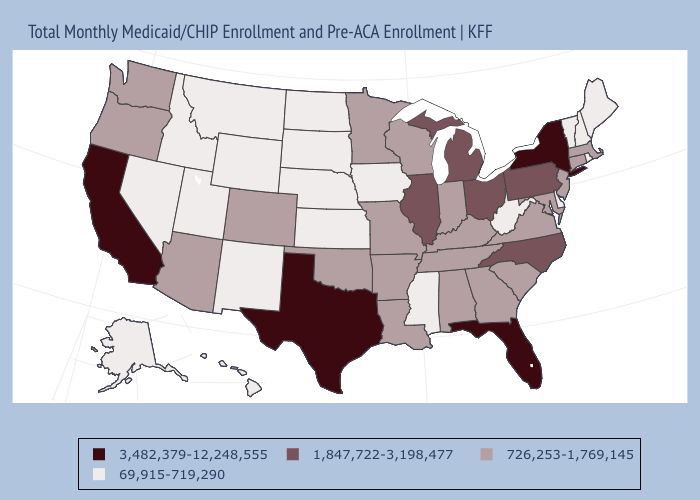What is the value of New York?
Write a very short answer. 3,482,379-12,248,555. Does Ohio have a higher value than Texas?
Short answer required. No. Name the states that have a value in the range 3,482,379-12,248,555?
Answer briefly. California, Florida, New York, Texas. What is the value of Maryland?
Answer briefly. 726,253-1,769,145. What is the highest value in the USA?
Be succinct. 3,482,379-12,248,555. Does Colorado have the same value as Wyoming?
Give a very brief answer. No. What is the value of Vermont?
Concise answer only. 69,915-719,290. What is the value of Minnesota?
Answer briefly. 726,253-1,769,145. Does Ohio have the lowest value in the USA?
Quick response, please. No. Among the states that border Kentucky , does Missouri have the lowest value?
Write a very short answer. No. Name the states that have a value in the range 3,482,379-12,248,555?
Answer briefly. California, Florida, New York, Texas. Which states have the highest value in the USA?
Write a very short answer. California, Florida, New York, Texas. Name the states that have a value in the range 3,482,379-12,248,555?
Quick response, please. California, Florida, New York, Texas. 